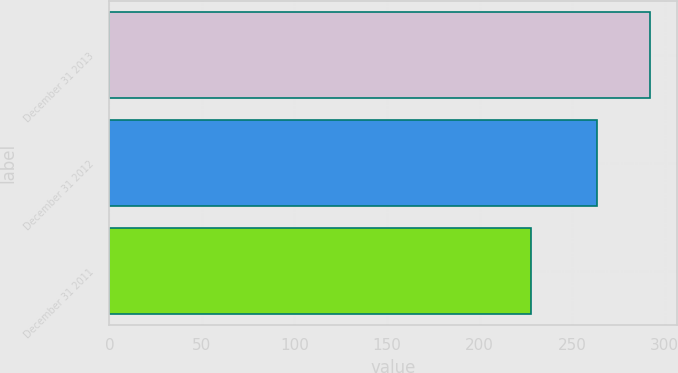Convert chart to OTSL. <chart><loc_0><loc_0><loc_500><loc_500><bar_chart><fcel>December 31 2013<fcel>December 31 2012<fcel>December 31 2011<nl><fcel>292.1<fcel>263.2<fcel>227.8<nl></chart> 